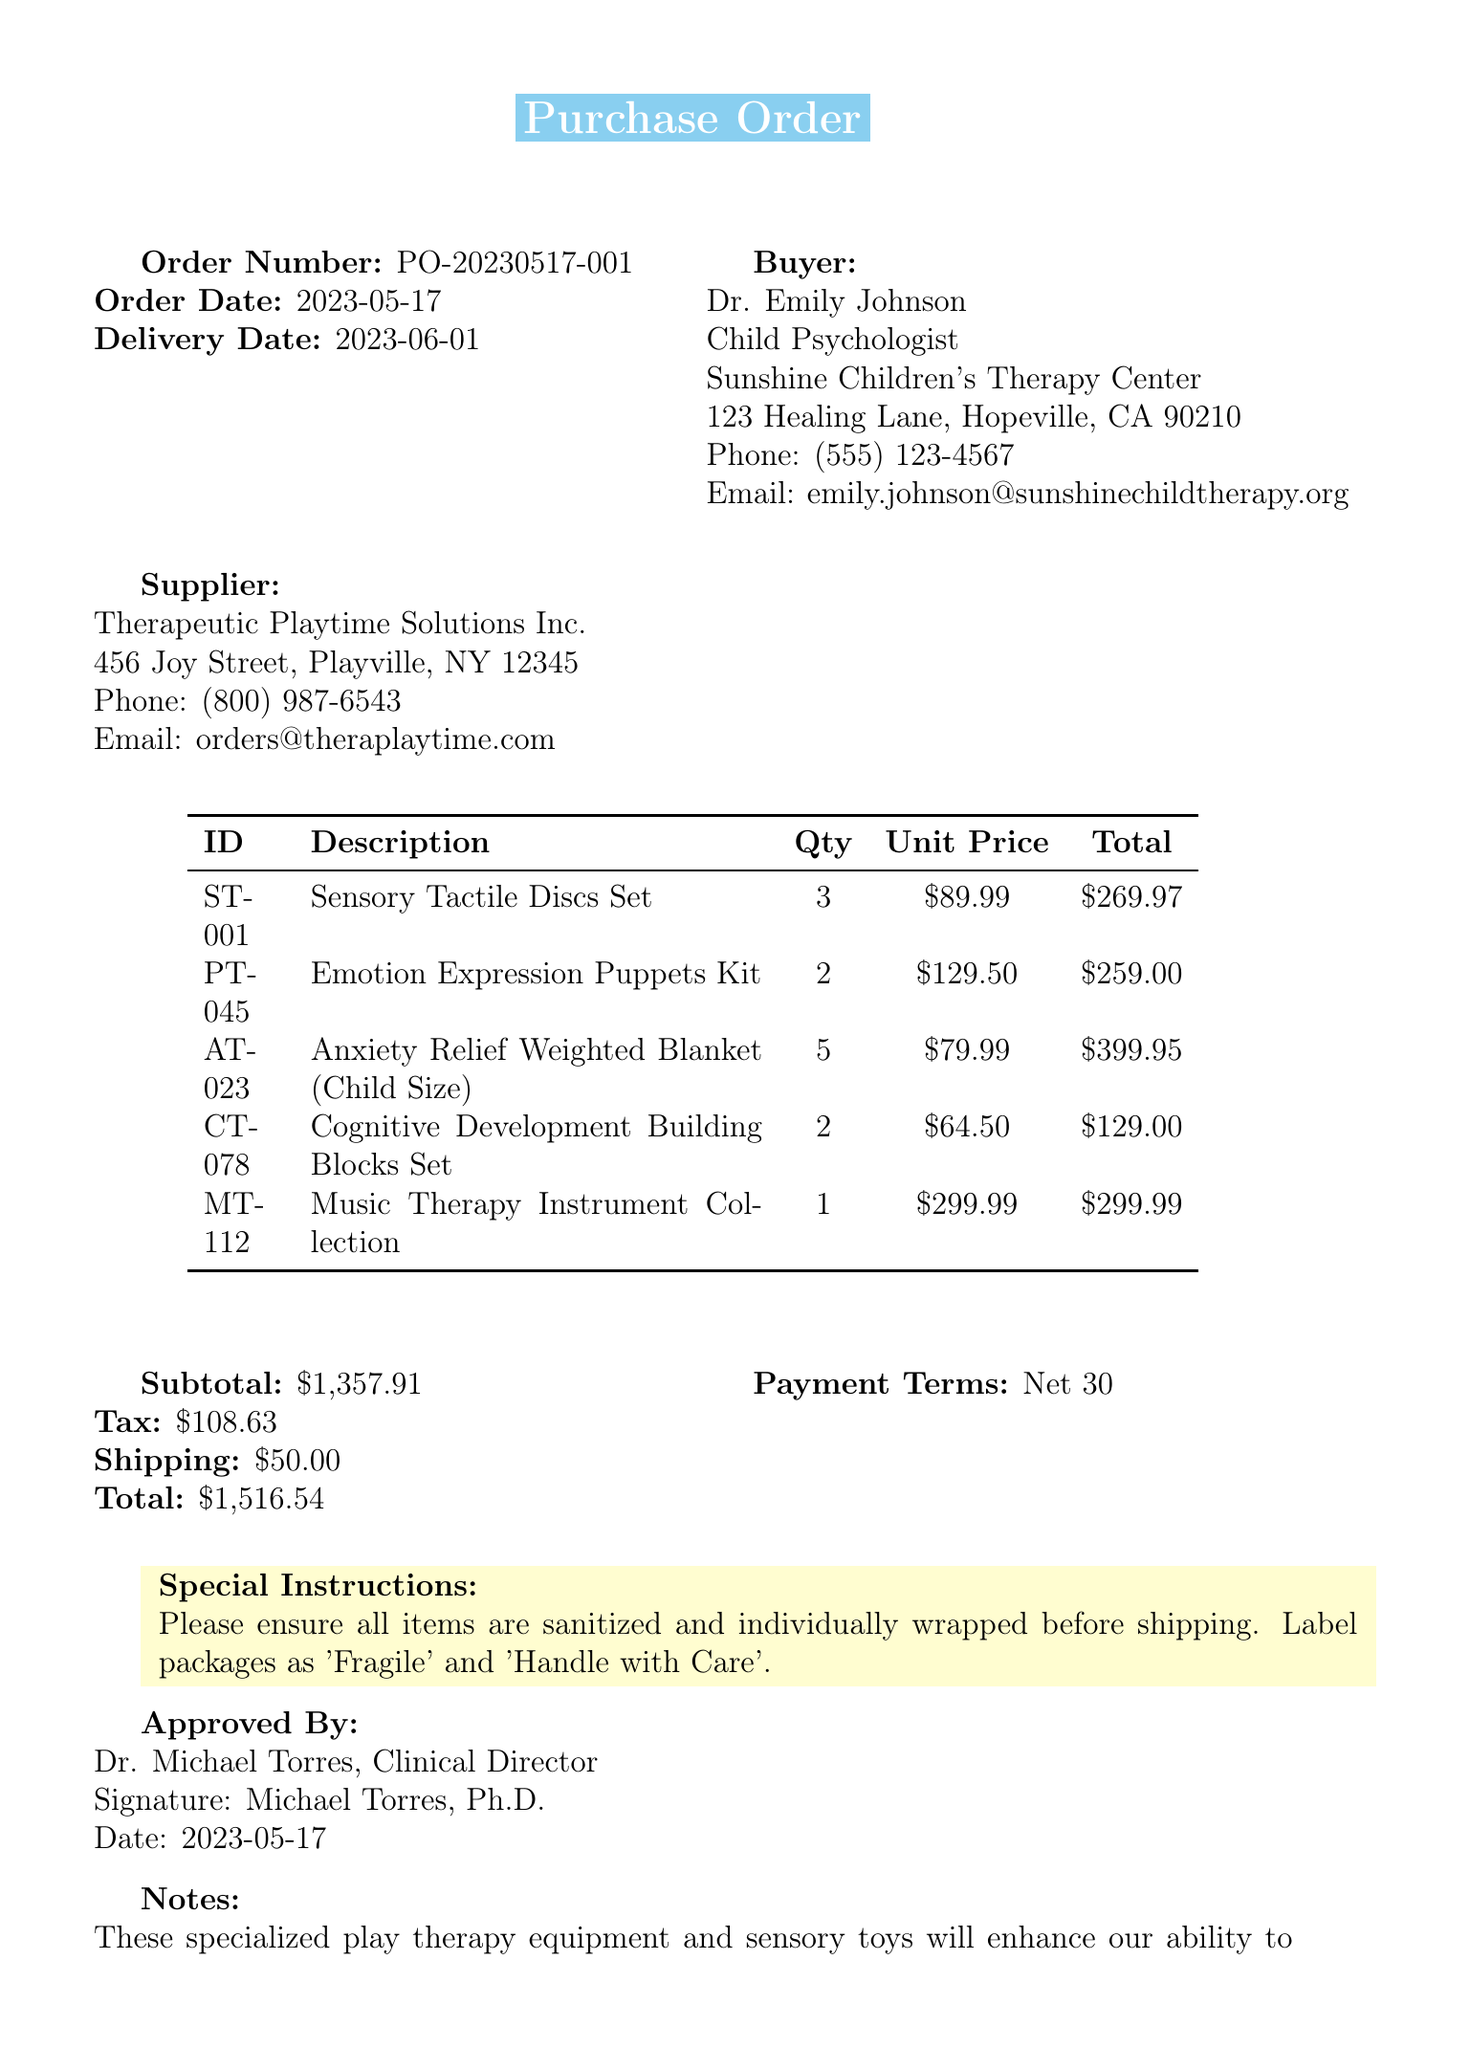what is the order number? The order number is a unique identifier for the purchase order, listed prominently in the document.
Answer: PO-20230517-001 who is the buyer? The buyer's name and role are specified in the document, indicating who is making the purchase.
Answer: Dr. Emily Johnson what is the total amount of the order? The total amount is calculated by summing up the subtotal, tax, and shipping costs.
Answer: $1,516.54 how many Anxiety Relief Weighted Blankets were ordered? The quantity of each item is explicitly stated in the items section of the document.
Answer: 5 what special instructions were included in the order? The special instructions provide important details about how to handle the items being shipped.
Answer: Please ensure all items are sanitized and individually wrapped before shipping. Label packages as 'Fragile' and 'Handle with Care' what is the payment term for this order? The payment terms clarify the financial agreement between the buyer and supplier regarding when payment is due.
Answer: Net 30 who approved the purchase order? The approval gives insight into who authorized the transaction within the organization.
Answer: Dr. Michael Torres what types of items were purchased? The document lists various items, categorized under play therapy equipment and sensory toys, which help in child therapy.
Answer: Sensory Tactile Discs Set, Emotion Expression Puppets Kit, Anxiety Relief Weighted Blanket, Cognitive Development Building Blocks Set, Music Therapy Instrument Collection when is the delivery date? The delivery date indicates when the buyer can expect to receive the items ordered.
Answer: 2023-06-01 